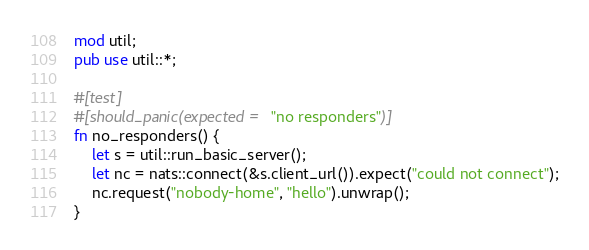<code> <loc_0><loc_0><loc_500><loc_500><_Rust_>mod util;
pub use util::*;

#[test]
#[should_panic(expected = "no responders")]
fn no_responders() {
    let s = util::run_basic_server();
    let nc = nats::connect(&s.client_url()).expect("could not connect");
    nc.request("nobody-home", "hello").unwrap();
}
</code> 